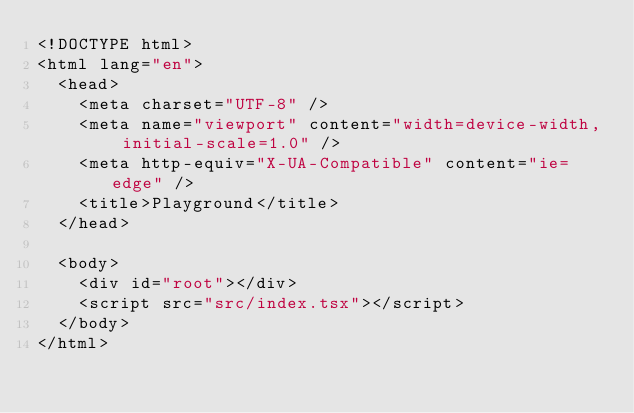<code> <loc_0><loc_0><loc_500><loc_500><_HTML_><!DOCTYPE html>
<html lang="en">
  <head>
    <meta charset="UTF-8" />
    <meta name="viewport" content="width=device-width, initial-scale=1.0" />
    <meta http-equiv="X-UA-Compatible" content="ie=edge" />
    <title>Playground</title>
  </head>

  <body>
    <div id="root"></div>
    <script src="src/index.tsx"></script>
  </body>
</html>
</code> 